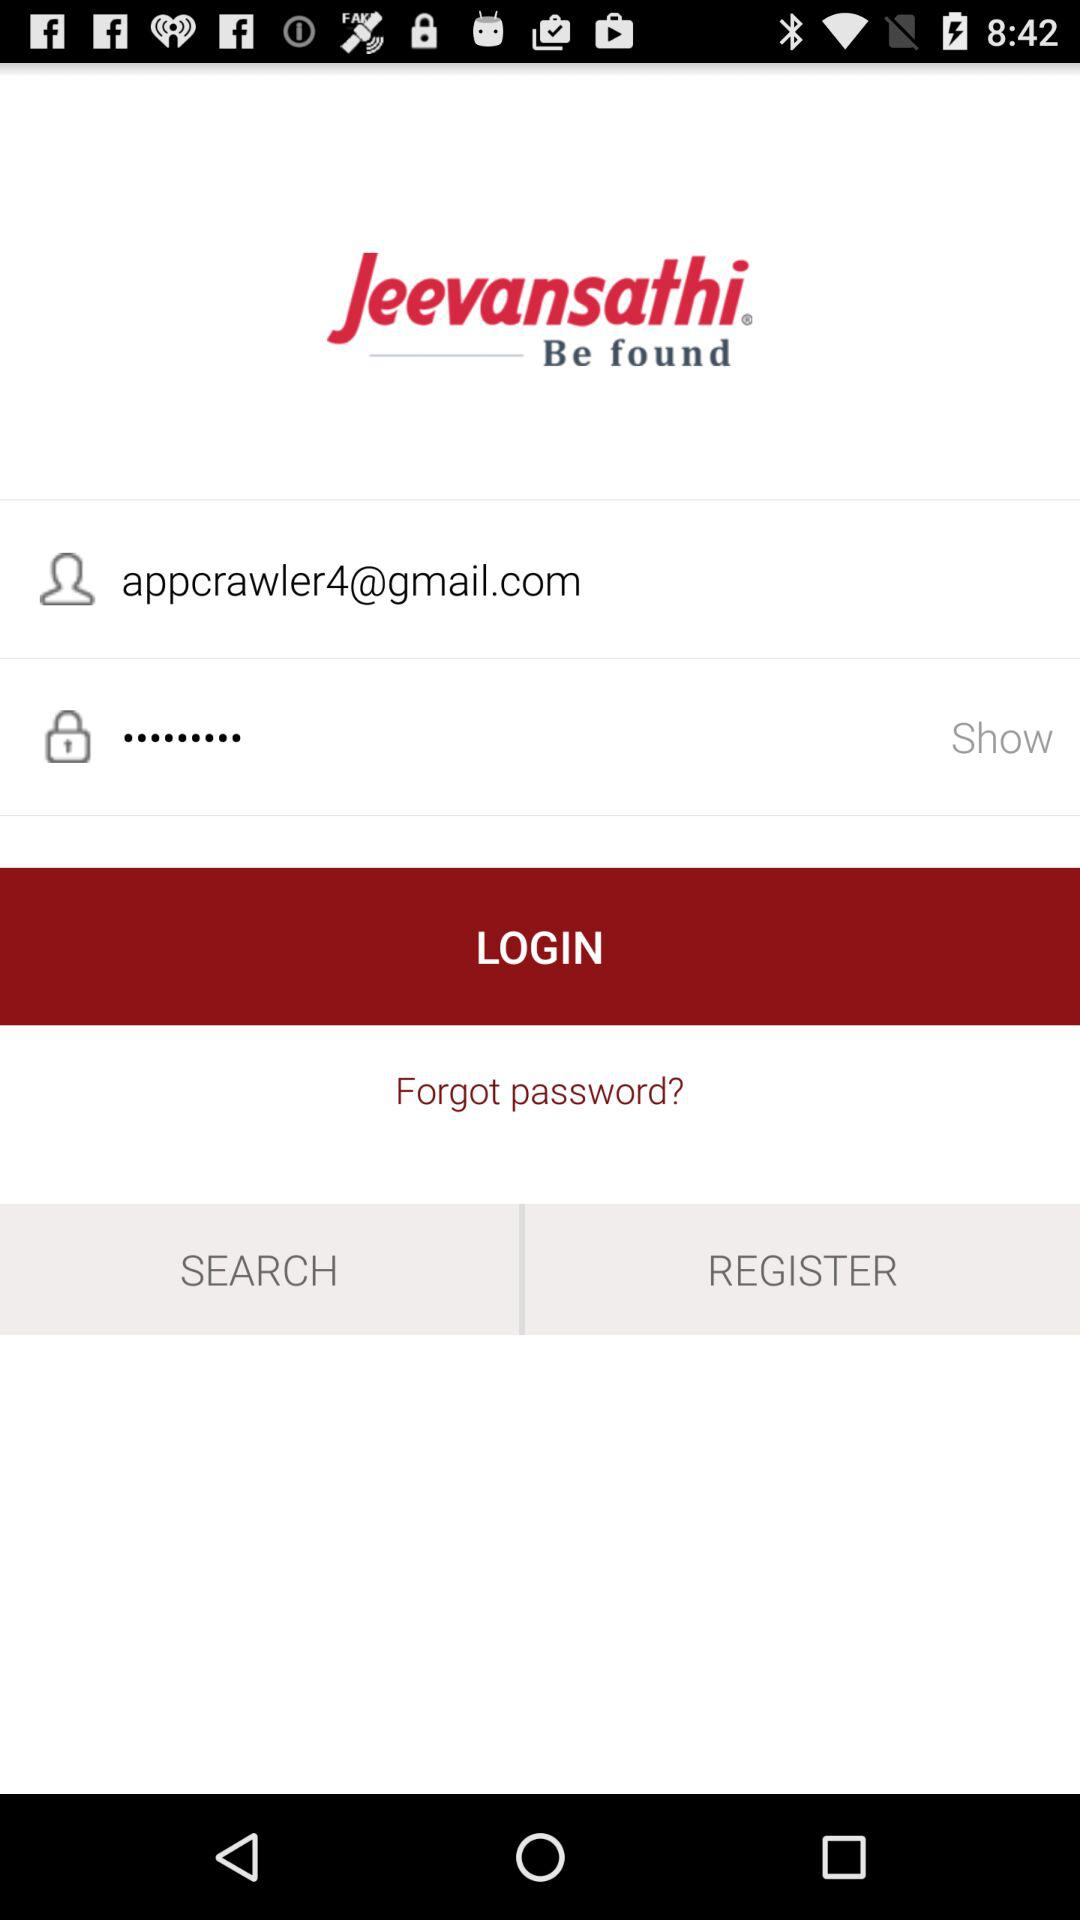What’s the app name? The app name is "Jeevansathi". 